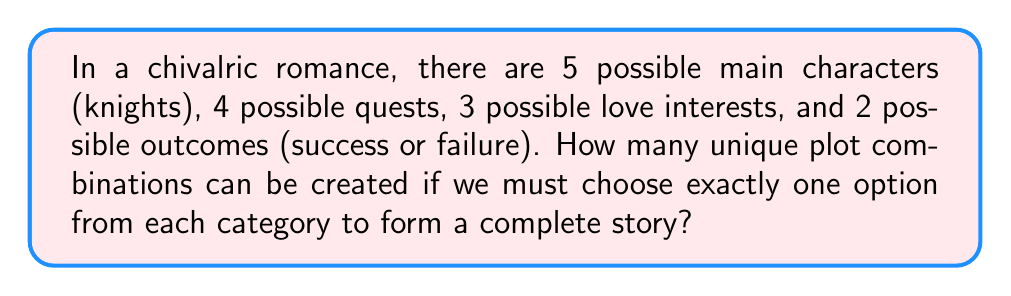What is the answer to this math problem? To solve this problem, we need to use the multiplication principle of counting. This principle states that if we have a sequence of choices, and each choice is independent of the others, we multiply the number of possibilities for each choice to get the total number of possible outcomes.

In this case, we have four independent choices to make:

1. Choose a main character (knight): 5 options
2. Choose a quest: 4 options
3. Choose a love interest: 3 options
4. Choose an outcome: 2 options

Since we must choose exactly one option from each category, and the order of selection doesn't matter (we're not arranging these elements), we simply multiply the number of options for each choice:

$$ \text{Total combinations} = 5 \times 4 \times 3 \times 2 $$

Calculating this:

$$ \text{Total combinations} = 5 \times 4 \times 3 \times 2 = 120 $$

This result gives us the total number of unique plot combinations possible in our chivalric romance scenario.

It's worth noting that this calculation method is similar to the fundamental counting principle used in probability theory, which is a key concept in discrete mathematics. In the context of Medieval Romance literature, this mathematical approach allows us to quantify the vast narrative possibilities within the genre's conventional elements.
Answer: $120$ unique plot combinations 